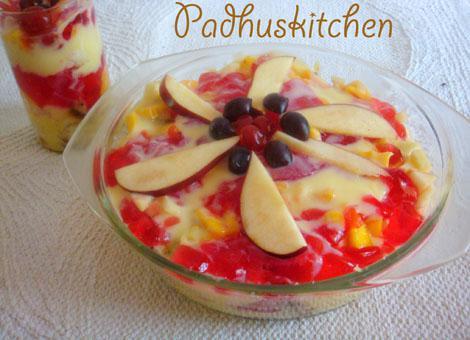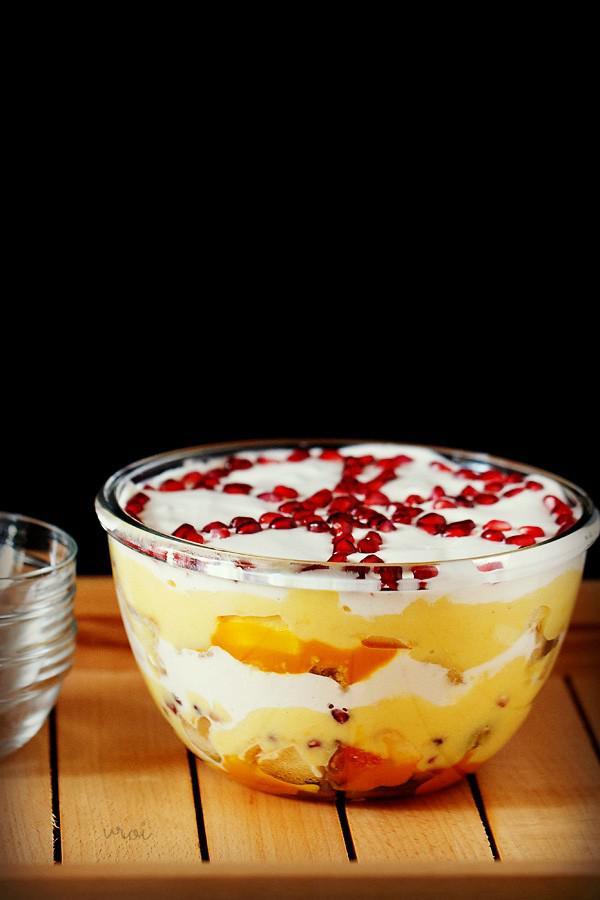The first image is the image on the left, the second image is the image on the right. Evaluate the accuracy of this statement regarding the images: "A trifle is garnished with pomegranite seeds arranged in a spoke pattern.". Is it true? Answer yes or no. Yes. 